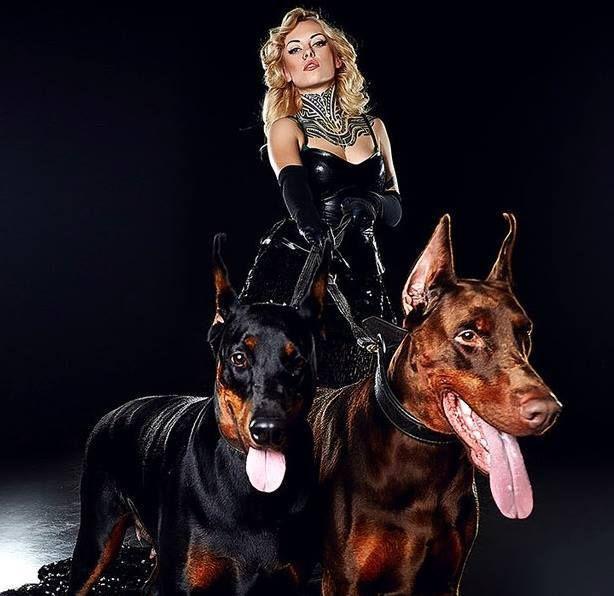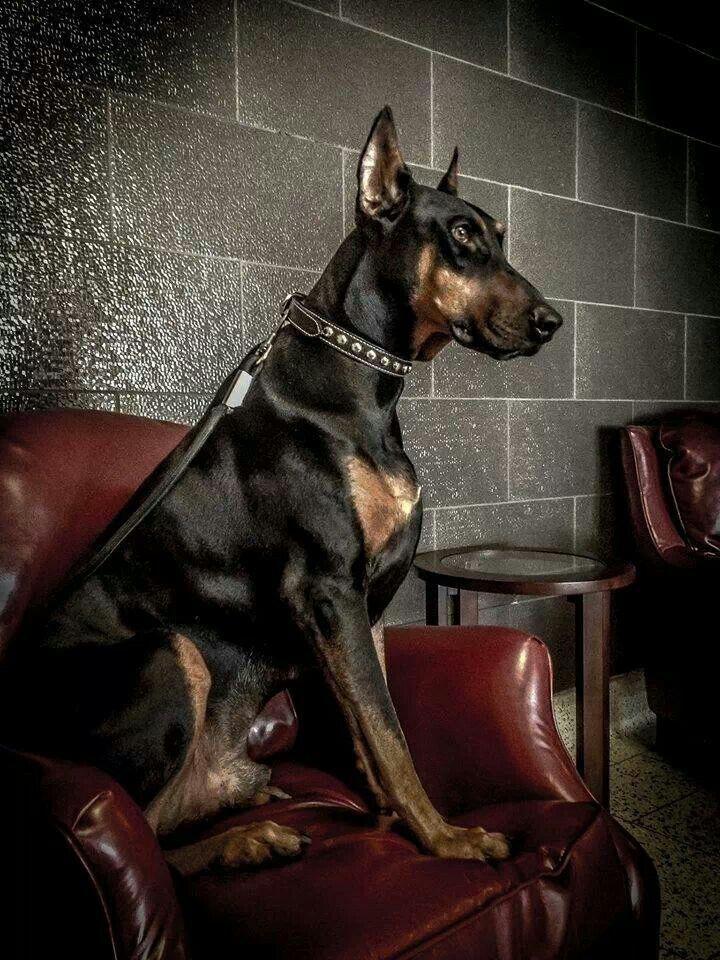The first image is the image on the left, the second image is the image on the right. For the images displayed, is the sentence "There are dobermans standing." factually correct? Answer yes or no. Yes. The first image is the image on the left, the second image is the image on the right. Assess this claim about the two images: "The combined images include at least four dogs, with at least two dogs in sitting poses and two dogs facing directly forward.". Correct or not? Answer yes or no. No. 